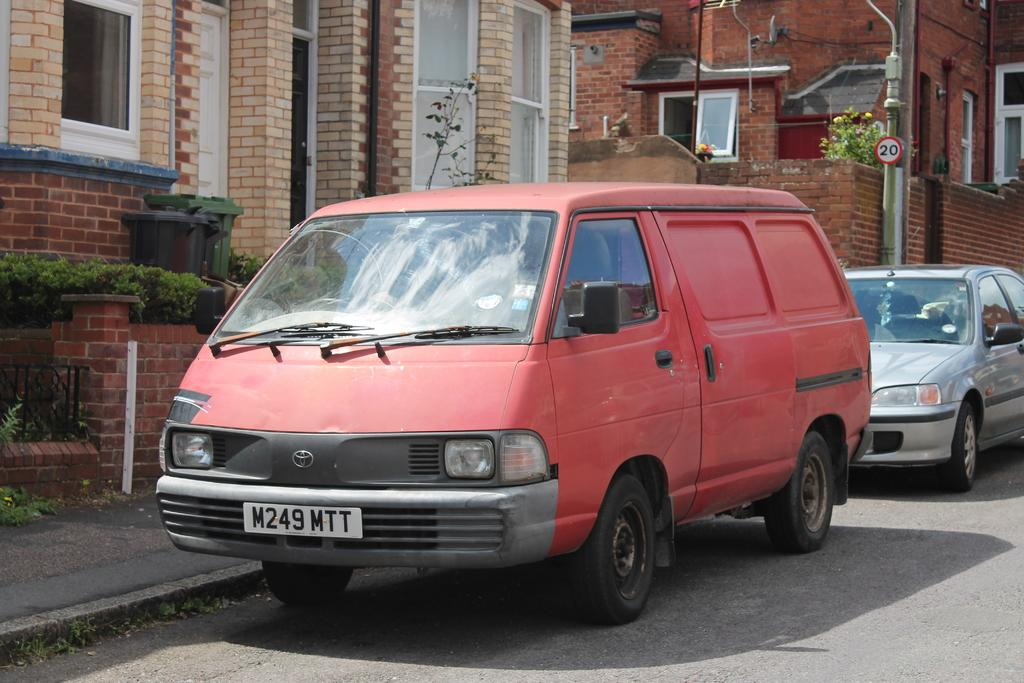<image>
Present a compact description of the photo's key features. A red van has a license that says M249MTT and is parked at the curb. 